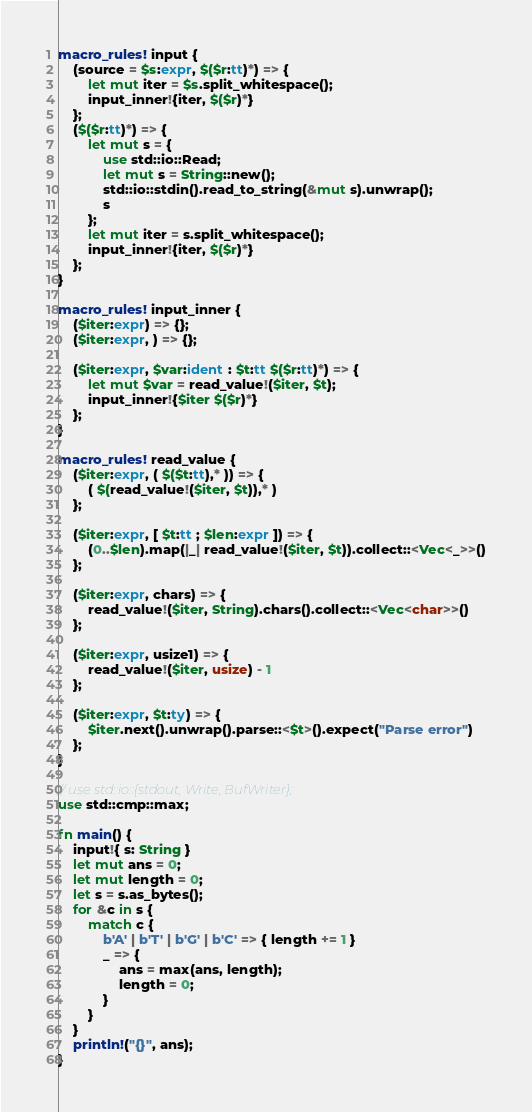Convert code to text. <code><loc_0><loc_0><loc_500><loc_500><_Rust_>macro_rules! input {
    (source = $s:expr, $($r:tt)*) => {
        let mut iter = $s.split_whitespace();
        input_inner!{iter, $($r)*}
    };
    ($($r:tt)*) => {
        let mut s = {
            use std::io::Read;
            let mut s = String::new();
            std::io::stdin().read_to_string(&mut s).unwrap();
            s
        };
        let mut iter = s.split_whitespace();
        input_inner!{iter, $($r)*}
    };
}

macro_rules! input_inner {
    ($iter:expr) => {};
    ($iter:expr, ) => {};

    ($iter:expr, $var:ident : $t:tt $($r:tt)*) => {
        let mut $var = read_value!($iter, $t);
        input_inner!{$iter $($r)*}
    };
}

macro_rules! read_value {
    ($iter:expr, ( $($t:tt),* )) => {
        ( $(read_value!($iter, $t)),* )
    };

    ($iter:expr, [ $t:tt ; $len:expr ]) => {
        (0..$len).map(|_| read_value!($iter, $t)).collect::<Vec<_>>()
    };

    ($iter:expr, chars) => {
        read_value!($iter, String).chars().collect::<Vec<char>>()
    };

    ($iter:expr, usize1) => {
        read_value!($iter, usize) - 1
    };

    ($iter:expr, $t:ty) => {
        $iter.next().unwrap().parse::<$t>().expect("Parse error")
    };
}

// use std::io::{stdout, Write, BufWriter};
use std::cmp::max;

fn main() {
    input!{ s: String }
    let mut ans = 0;
    let mut length = 0;
    let s = s.as_bytes();
    for &c in s {
        match c {
            b'A' | b'T' | b'G' | b'C' => { length += 1 }
            _ => {
                ans = max(ans, length);
                length = 0;
            }
        }
    }
    println!("{}", ans);
}
</code> 